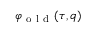<formula> <loc_0><loc_0><loc_500><loc_500>\varphi _ { o l d } ( \tau , q )</formula> 